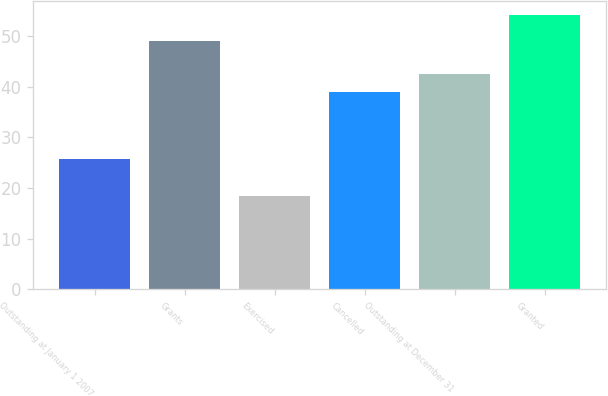Convert chart. <chart><loc_0><loc_0><loc_500><loc_500><bar_chart><fcel>Outstanding at January 1 2007<fcel>Grants<fcel>Exercised<fcel>Cancelled<fcel>Outstanding at December 31<fcel>Granted<nl><fcel>25.61<fcel>49.01<fcel>18.37<fcel>38.99<fcel>42.56<fcel>54.08<nl></chart> 